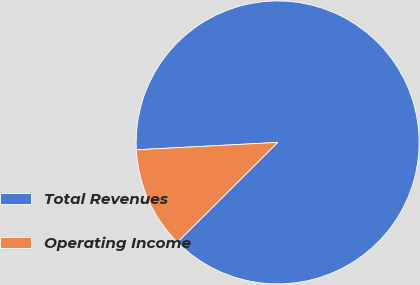Convert chart to OTSL. <chart><loc_0><loc_0><loc_500><loc_500><pie_chart><fcel>Total Revenues<fcel>Operating Income<nl><fcel>88.36%<fcel>11.64%<nl></chart> 